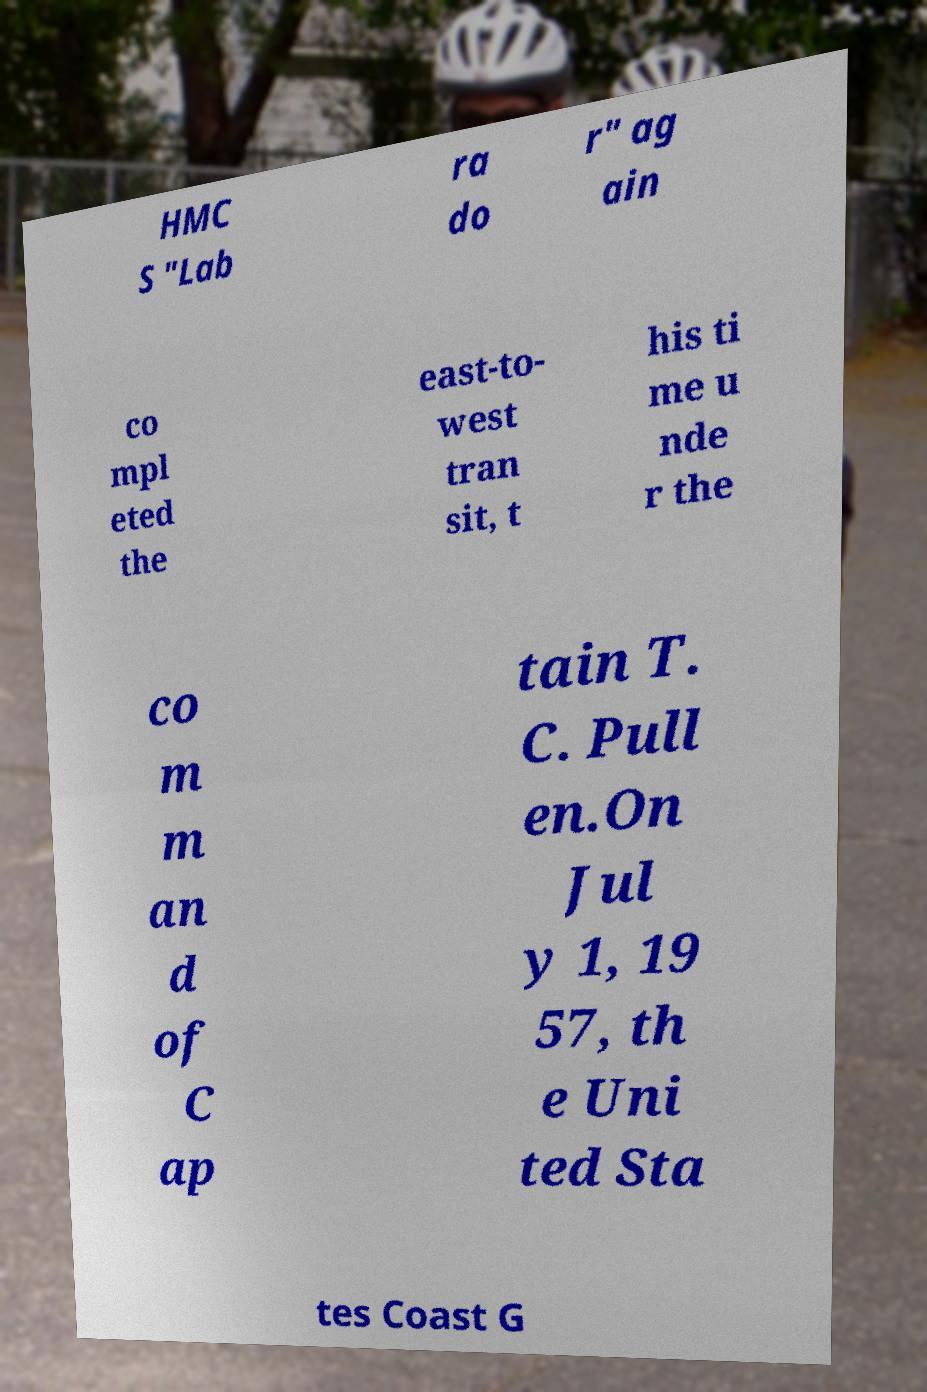Could you extract and type out the text from this image? HMC S "Lab ra do r" ag ain co mpl eted the east-to- west tran sit, t his ti me u nde r the co m m an d of C ap tain T. C. Pull en.On Jul y 1, 19 57, th e Uni ted Sta tes Coast G 